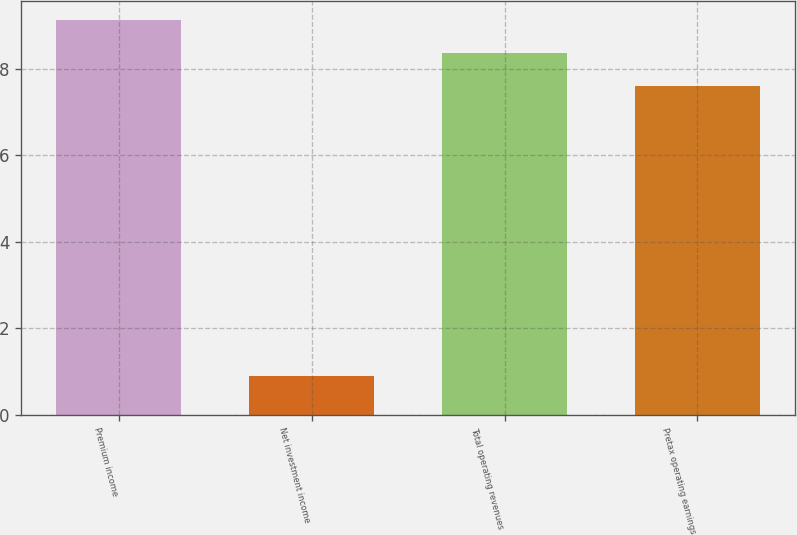<chart> <loc_0><loc_0><loc_500><loc_500><bar_chart><fcel>Premium income<fcel>Net investment income<fcel>Total operating revenues<fcel>Pretax operating earnings<nl><fcel>9.12<fcel>0.9<fcel>8.36<fcel>7.6<nl></chart> 